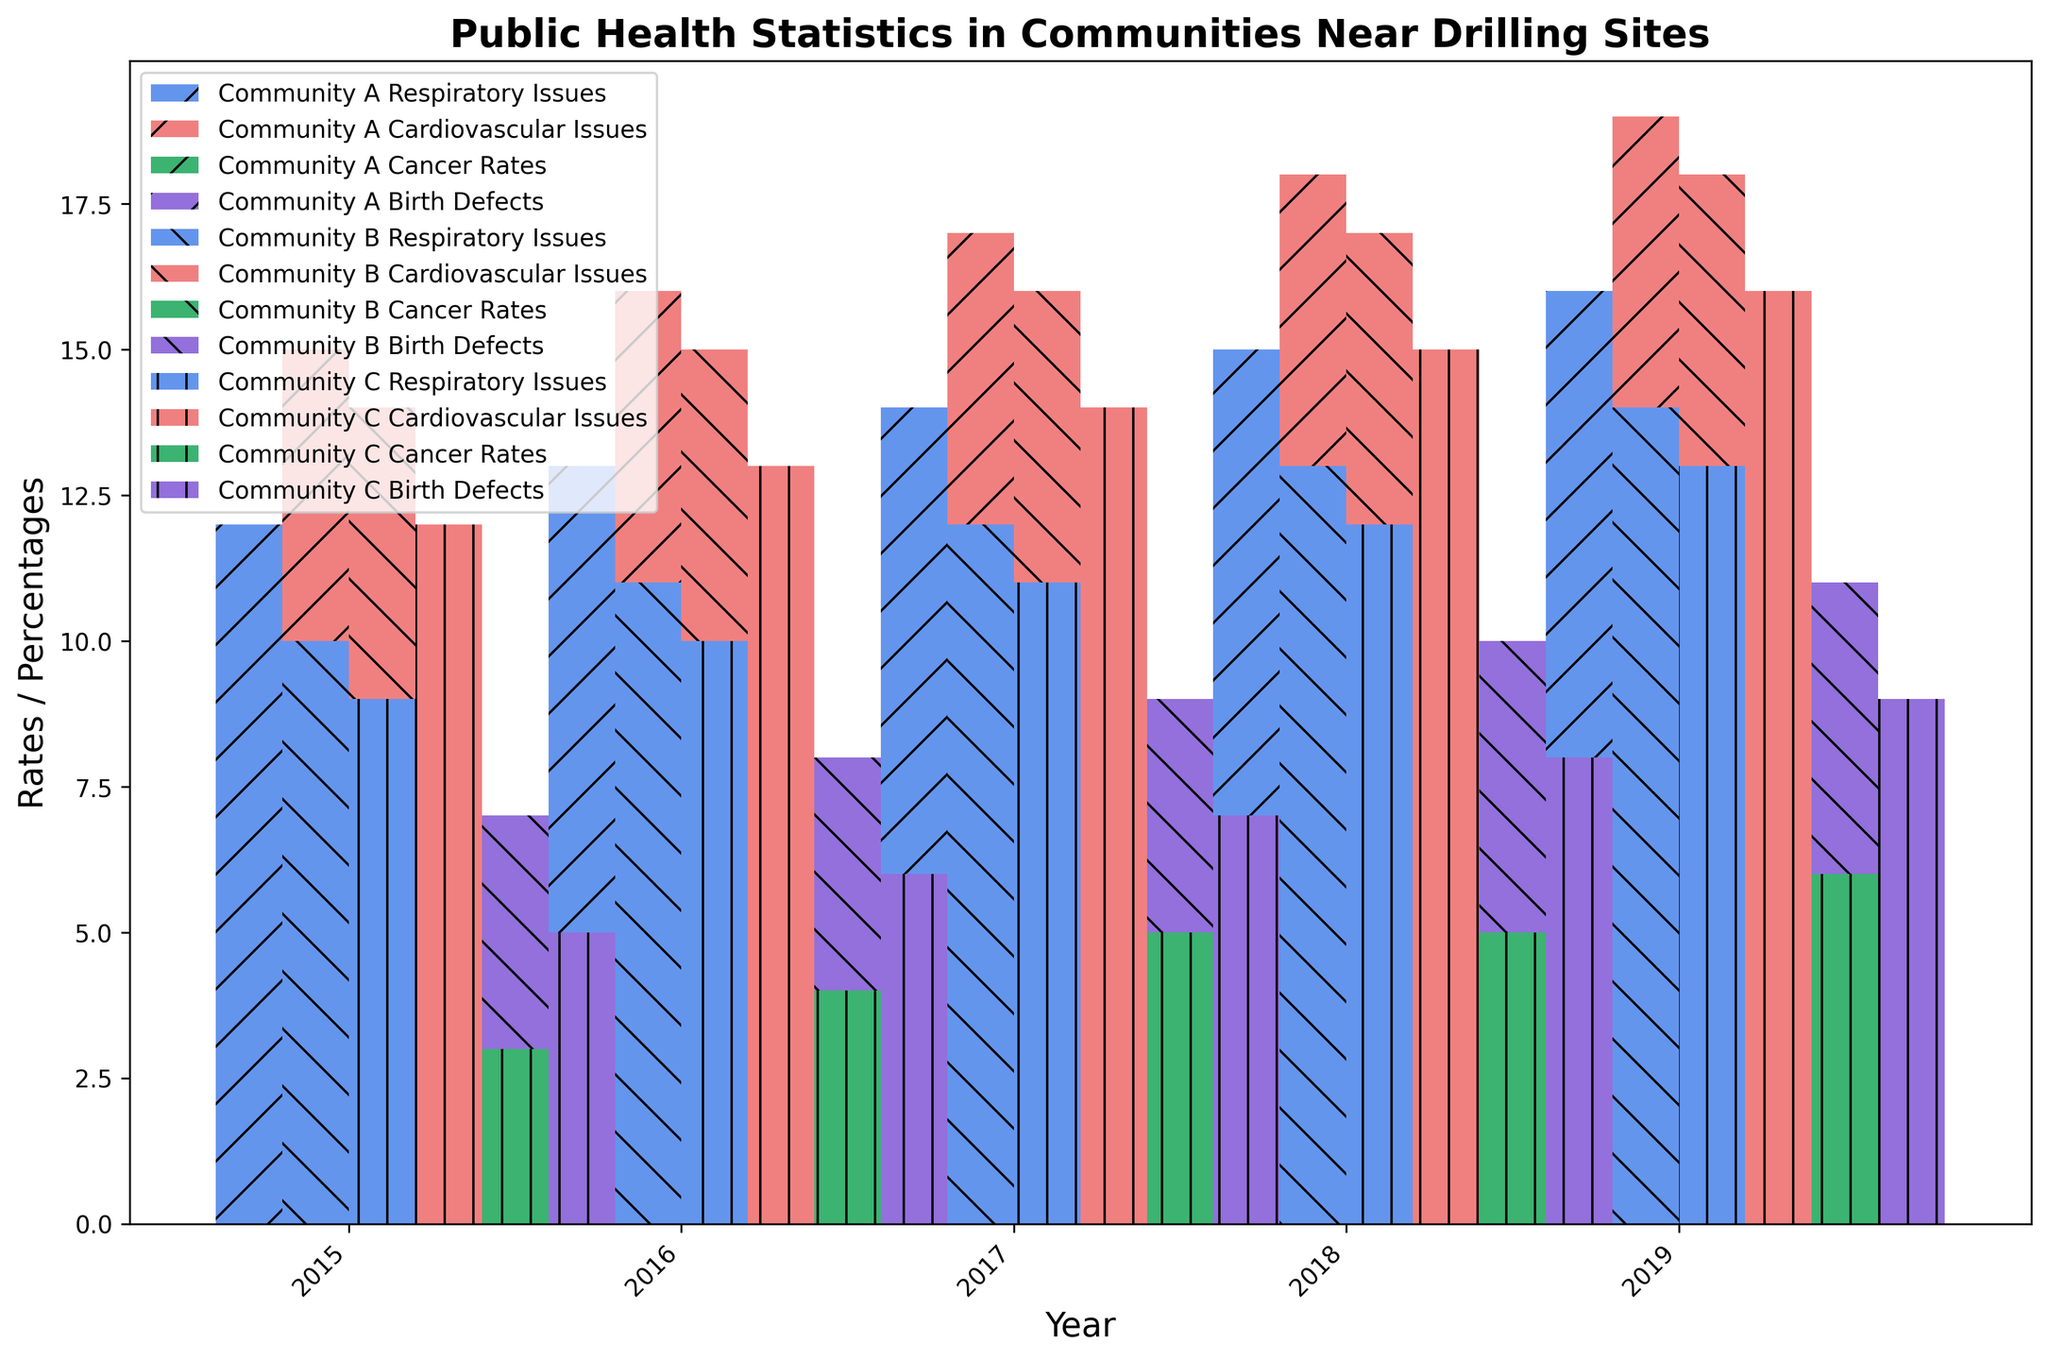What year did Community A have the highest percentage of respiratory issues? Observing the height of the bars corresponding to "Community A Respiratory Issues" across all years, the highest bar is in 2019.
Answer: 2019 Which community had the lowest cardiovascular issues in 2016? Comparing the height of the bars corresponding to "Cardiovascular Issues" for all three communities in 2016, Community C has the lowest.
Answer: Community C How did the cancer rates in Community B change from 2015 to 2019? Subtract the height of the "Cancer Rates" bar for Community B in 2015 from the height of the same in 2019 (i.e., 7 - 4).
Answer: Increased by 3 What is the average percentage of respiratory issues in Community C over the years shown? Sum the respiratory issues percentages for Community C over all years ((9 + 10 + 11 + 12 + 13) = 55) and divide by the number of years (5).
Answer: 11% How do birth defect rates in Community A in 2019 compare to Community B the same year? By looking at the heights of the birth defect bars for both communities in 2019, Community A's bar height is higher than Community B.
Answer: Community A has higher rates Between 2015 and 2019, which year saw the greatest increase in cardiovascular issues in Community A? Calculate the differences in cardiovascular issues percentages for Community A year over year ((16-15), (17-16), (18-17), (19-18)). The greatest difference is between 2018 and 2019 (19-18).
Answer: 2018-2019 What visual pattern can you observe in the change of respiratory issues for Community B over the years? Analyzing the height of the bars for "Community B Respiratory Issues" from 2015 to 2019, there is a consistent increase.
Answer: Consistent increase Which community showed the smallest change in cancer rates between 2017 and 2019? Comparing the heights of the cancer rates bars for all three communities between 2017 and 2019, Community A and B’s bars both increased by 1 (6 to 8 for A and 5 to 7 for B), but Community C's bars showed no change (both 5).
Answer: Community C 